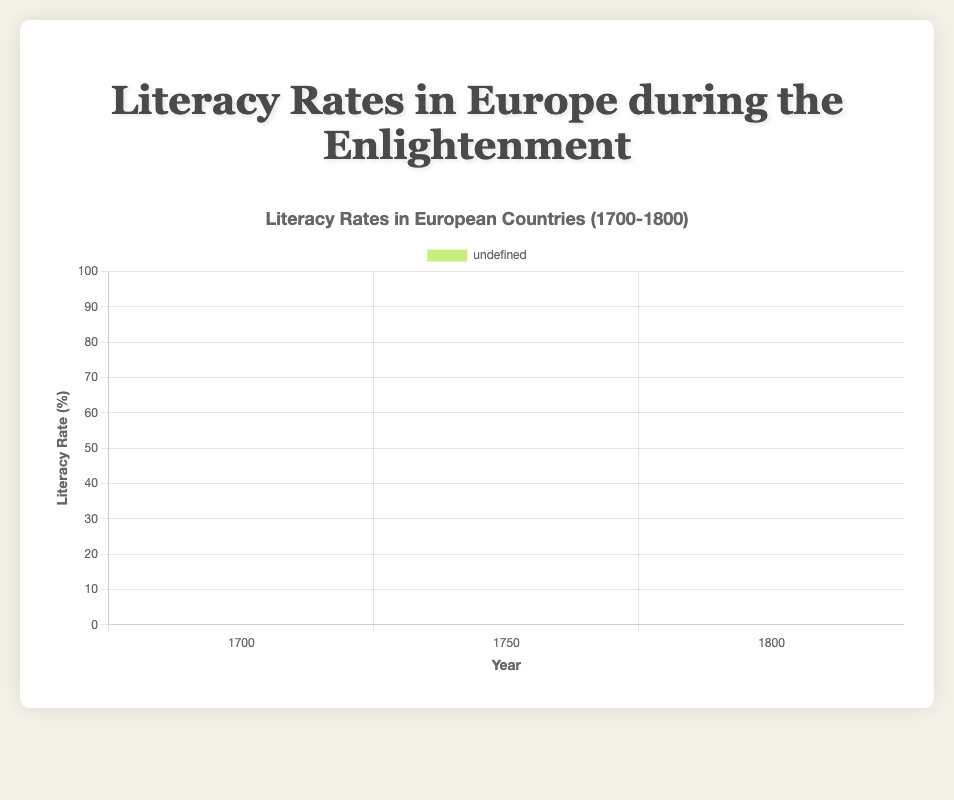Which country had the highest literacy rate in 1700? Check the bar heights for each country in 1700 and see which one is the tallest. The Netherlands has the highest literacy rate with a rate of 50%.
Answer: Netherlands How did the literacy rate in Italy change from 1700 to 1800? Look at the bar heights for Italy for the years 1700 and 1800. Italy's literacy rate increased from 26% in 1700 to 40% in 1800.
Answer: Increased from 26% to 40% Which country showed the greatest increase in literacy rate from 1700 to 1750? Compare the differences between the bars of 1700 and 1750 for each country. The largest increase is seen in England, from 40% to 53%, which is a 13% increase.
Answer: England How does the literacy rate of Spain in 1750 compare to that of France in the same year? Compare the bar heights for Spain and France in 1750. Spain's literacy rate is 29% in 1750, while France's is 39%.
Answer: Spain's literacy rate is lower than France's by 10% What is the average literacy rate of France across the three time points? Sum the literacy rates of France in 1700, 1750, and 1800, then divide by 3. (29 + 39 + 47) / 3 = 115 / 3 ≈ 38.33%.
Answer: Approximately 38.33% Between Germany and Netherlands, which country had consistently higher literacy rates across all three years? Compare the bars of Germany and Netherlands for 1700, 1750, and 1800. The Netherlands consistently had higher literacy rates (50%, 60%, 68%) compared to Germany (35%, 50%, 60%).
Answer: Netherlands What is the difference in literacy rate between the country with the highest and lowest rates in 1800? Identify the country with the highest rate in 1800 (Netherlands, 68%) and the country with the lowest rate (Spain, 36%), then calculate the difference. 68% - 36% = 32%.
Answer: 32% Which countries had a literacy rate above 50% in 1750? Examine the bars for each country in 1750. Only England (53%) and Netherlands (60%) had literacy rates above 50%.
Answer: England and Netherlands What is the total increase in literacy rate for Germany from 1700 to 1800? Determine the difference in literacy rates for Germany between 1700 (35%) and 1800 (60%). 60% - 35% = 25%.
Answer: 25% How does the average literacy rate of England in 1700 and 1800 compare to the literacy rate in France in 1750? Calculate the average of England's literacy rates in 1700 and 1800 (40% + 62%) / 2 = 51%, then compare it to France's rate in 1750, which is 39%.
Answer: England's average is higher than France's 1750 rate by 12% 